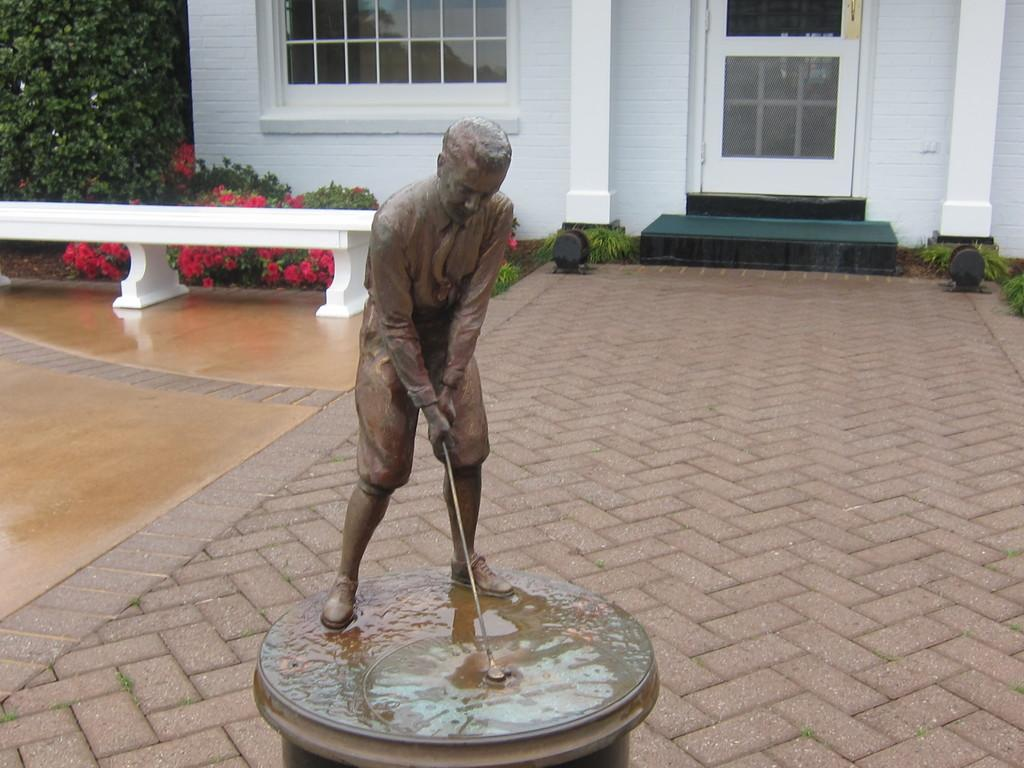What is the main subject of the image? There is a statue of a man in the image. What is the statue holding? The statue is holding a stick. What can be seen behind the statue? There are plants and trees behind the statue, as well as a building with a door and a glass window. How does the statue sort items in the image? The statue is not sorting items in the image; it is a stationary sculpture. What type of arm is the statue using to hold the stick? The statue does not have a physical arm, as it is a sculpture made of a material such as stone or metal. 